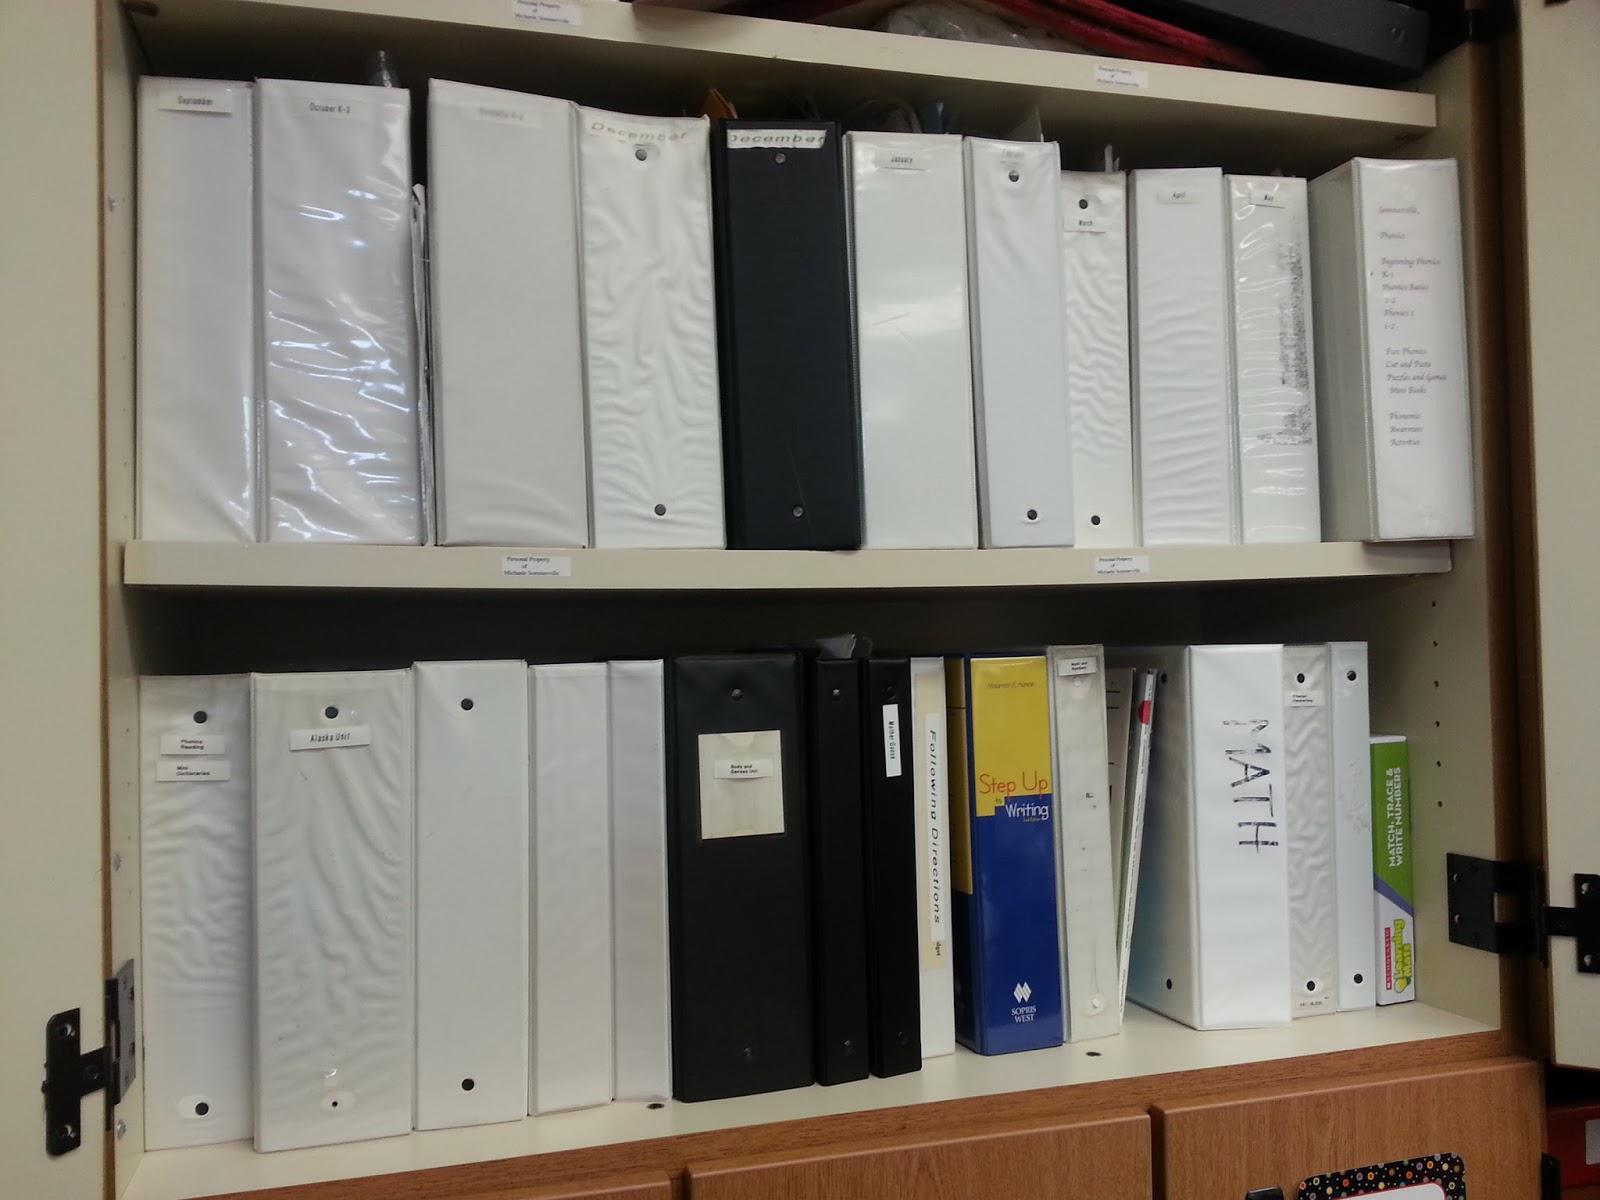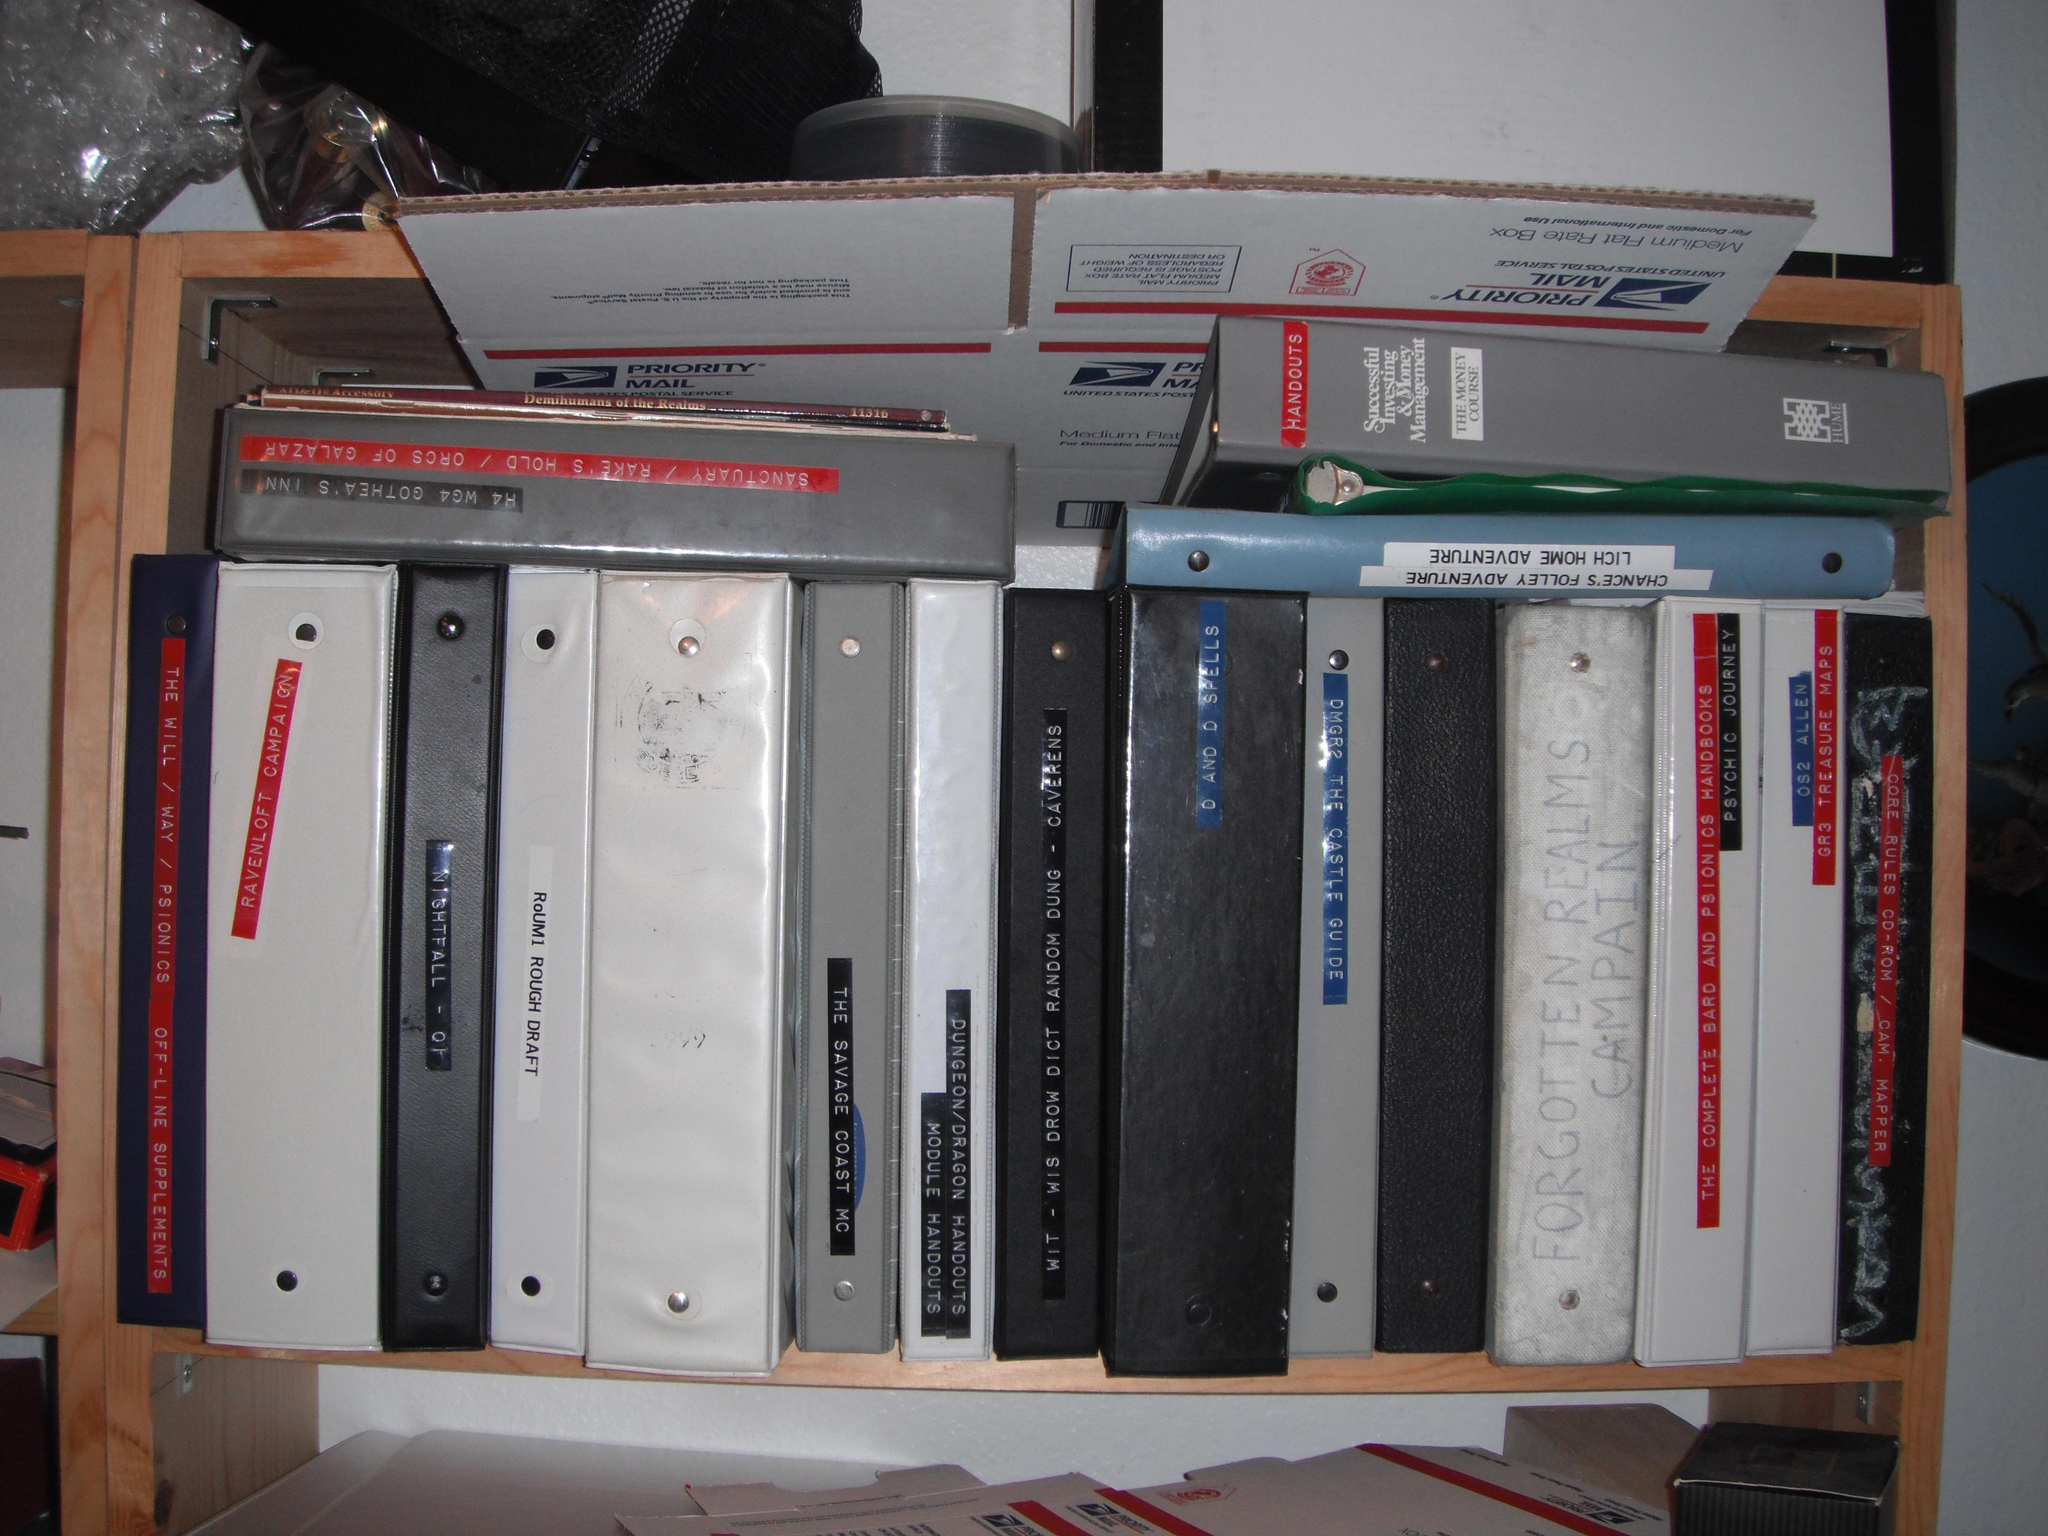The first image is the image on the left, the second image is the image on the right. Considering the images on both sides, is "An image shows one row of colored folders with rectangular white labels on the binding." valid? Answer yes or no. No. The first image is the image on the left, the second image is the image on the right. Assess this claim about the two images: "there are no more than seven binders in one of the images". Correct or not? Answer yes or no. No. 